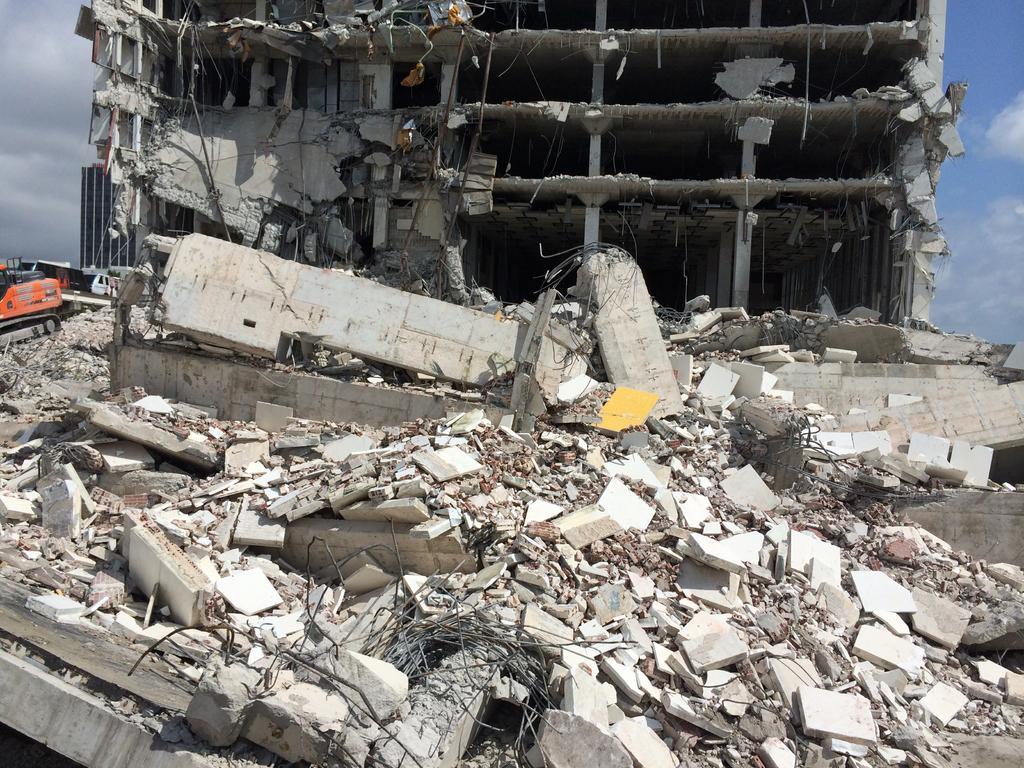Could you give a brief overview of what you see in this image? In this image in front there is a damaged building. Beside that there is a JCB truck. In the background of the image there is a building and sky. 